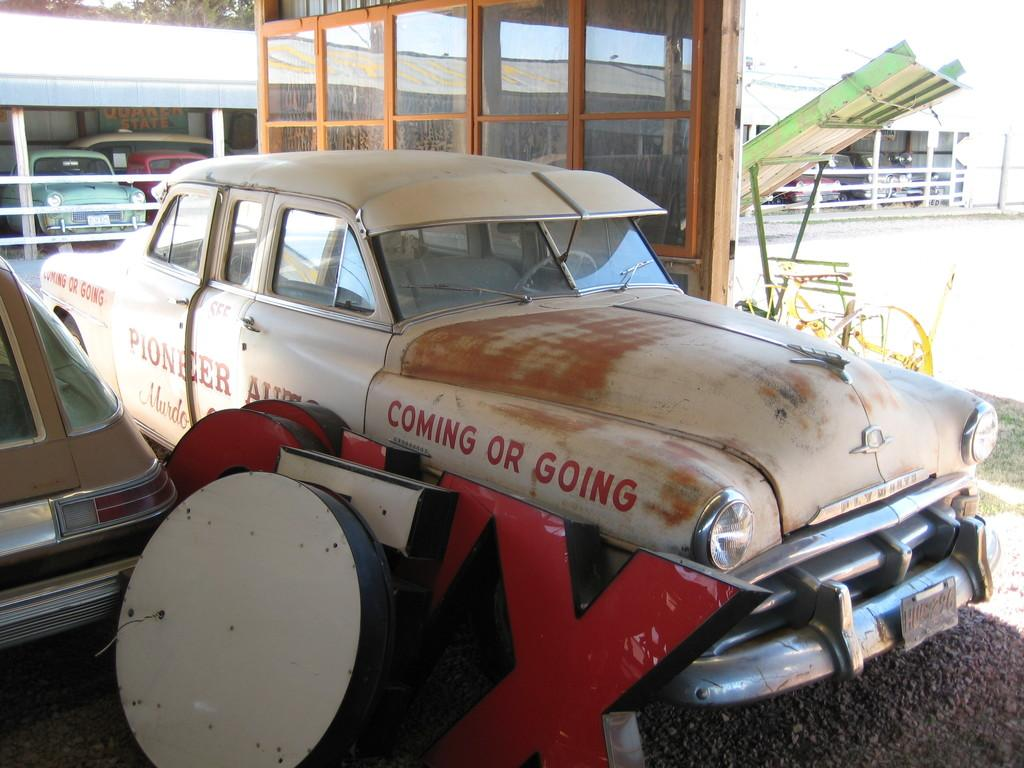<image>
Create a compact narrative representing the image presented. A vintage Plymouth car owned by Pioneer Auto has the words Coming or Going written on the side 